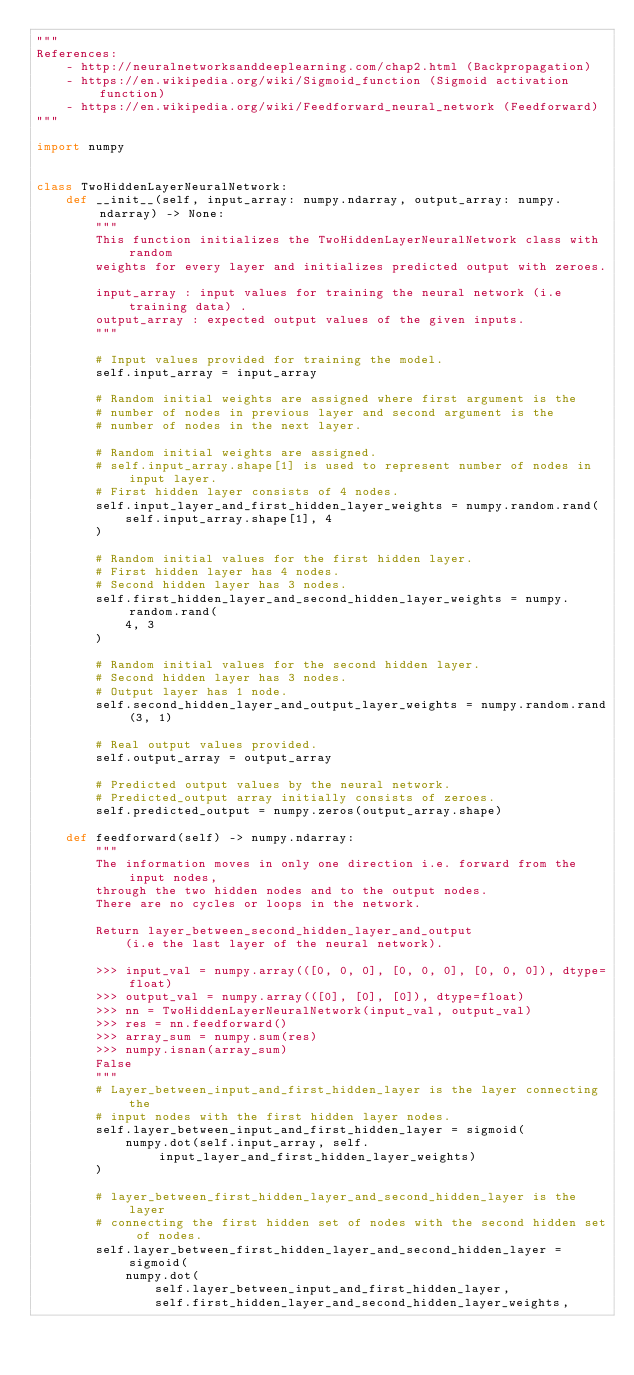<code> <loc_0><loc_0><loc_500><loc_500><_Python_>"""
References:
    - http://neuralnetworksanddeeplearning.com/chap2.html (Backpropagation)
    - https://en.wikipedia.org/wiki/Sigmoid_function (Sigmoid activation function)
    - https://en.wikipedia.org/wiki/Feedforward_neural_network (Feedforward)
"""

import numpy


class TwoHiddenLayerNeuralNetwork:
    def __init__(self, input_array: numpy.ndarray, output_array: numpy.ndarray) -> None:
        """
        This function initializes the TwoHiddenLayerNeuralNetwork class with random
        weights for every layer and initializes predicted output with zeroes.

        input_array : input values for training the neural network (i.e training data) .
        output_array : expected output values of the given inputs.
        """

        # Input values provided for training the model.
        self.input_array = input_array

        # Random initial weights are assigned where first argument is the
        # number of nodes in previous layer and second argument is the
        # number of nodes in the next layer.

        # Random initial weights are assigned.
        # self.input_array.shape[1] is used to represent number of nodes in input layer.
        # First hidden layer consists of 4 nodes.
        self.input_layer_and_first_hidden_layer_weights = numpy.random.rand(
            self.input_array.shape[1], 4
        )

        # Random initial values for the first hidden layer.
        # First hidden layer has 4 nodes.
        # Second hidden layer has 3 nodes.
        self.first_hidden_layer_and_second_hidden_layer_weights = numpy.random.rand(
            4, 3
        )

        # Random initial values for the second hidden layer.
        # Second hidden layer has 3 nodes.
        # Output layer has 1 node.
        self.second_hidden_layer_and_output_layer_weights = numpy.random.rand(3, 1)

        # Real output values provided.
        self.output_array = output_array

        # Predicted output values by the neural network.
        # Predicted_output array initially consists of zeroes.
        self.predicted_output = numpy.zeros(output_array.shape)

    def feedforward(self) -> numpy.ndarray:
        """
        The information moves in only one direction i.e. forward from the input nodes,
        through the two hidden nodes and to the output nodes.
        There are no cycles or loops in the network.

        Return layer_between_second_hidden_layer_and_output
            (i.e the last layer of the neural network).

        >>> input_val = numpy.array(([0, 0, 0], [0, 0, 0], [0, 0, 0]), dtype=float)
        >>> output_val = numpy.array(([0], [0], [0]), dtype=float)
        >>> nn = TwoHiddenLayerNeuralNetwork(input_val, output_val)
        >>> res = nn.feedforward()
        >>> array_sum = numpy.sum(res)
        >>> numpy.isnan(array_sum)
        False
        """
        # Layer_between_input_and_first_hidden_layer is the layer connecting the
        # input nodes with the first hidden layer nodes.
        self.layer_between_input_and_first_hidden_layer = sigmoid(
            numpy.dot(self.input_array, self.input_layer_and_first_hidden_layer_weights)
        )

        # layer_between_first_hidden_layer_and_second_hidden_layer is the layer
        # connecting the first hidden set of nodes with the second hidden set of nodes.
        self.layer_between_first_hidden_layer_and_second_hidden_layer = sigmoid(
            numpy.dot(
                self.layer_between_input_and_first_hidden_layer,
                self.first_hidden_layer_and_second_hidden_layer_weights,</code> 